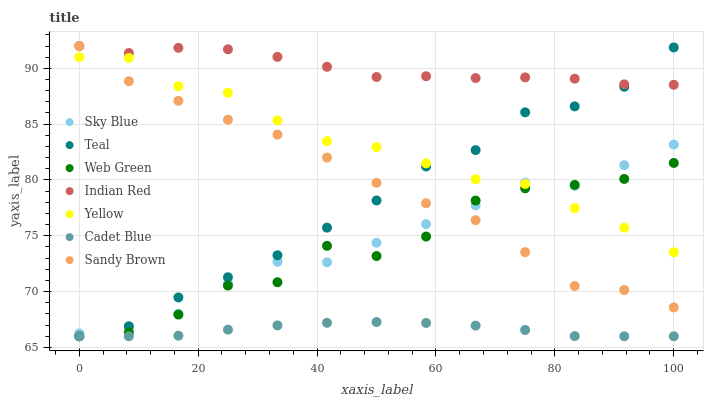Does Cadet Blue have the minimum area under the curve?
Answer yes or no. Yes. Does Indian Red have the maximum area under the curve?
Answer yes or no. Yes. Does Teal have the minimum area under the curve?
Answer yes or no. No. Does Teal have the maximum area under the curve?
Answer yes or no. No. Is Cadet Blue the smoothest?
Answer yes or no. Yes. Is Web Green the roughest?
Answer yes or no. Yes. Is Teal the smoothest?
Answer yes or no. No. Is Teal the roughest?
Answer yes or no. No. Does Cadet Blue have the lowest value?
Answer yes or no. Yes. Does Yellow have the lowest value?
Answer yes or no. No. Does Sandy Brown have the highest value?
Answer yes or no. Yes. Does Teal have the highest value?
Answer yes or no. No. Is Web Green less than Indian Red?
Answer yes or no. Yes. Is Indian Red greater than Web Green?
Answer yes or no. Yes. Does Sky Blue intersect Sandy Brown?
Answer yes or no. Yes. Is Sky Blue less than Sandy Brown?
Answer yes or no. No. Is Sky Blue greater than Sandy Brown?
Answer yes or no. No. Does Web Green intersect Indian Red?
Answer yes or no. No. 